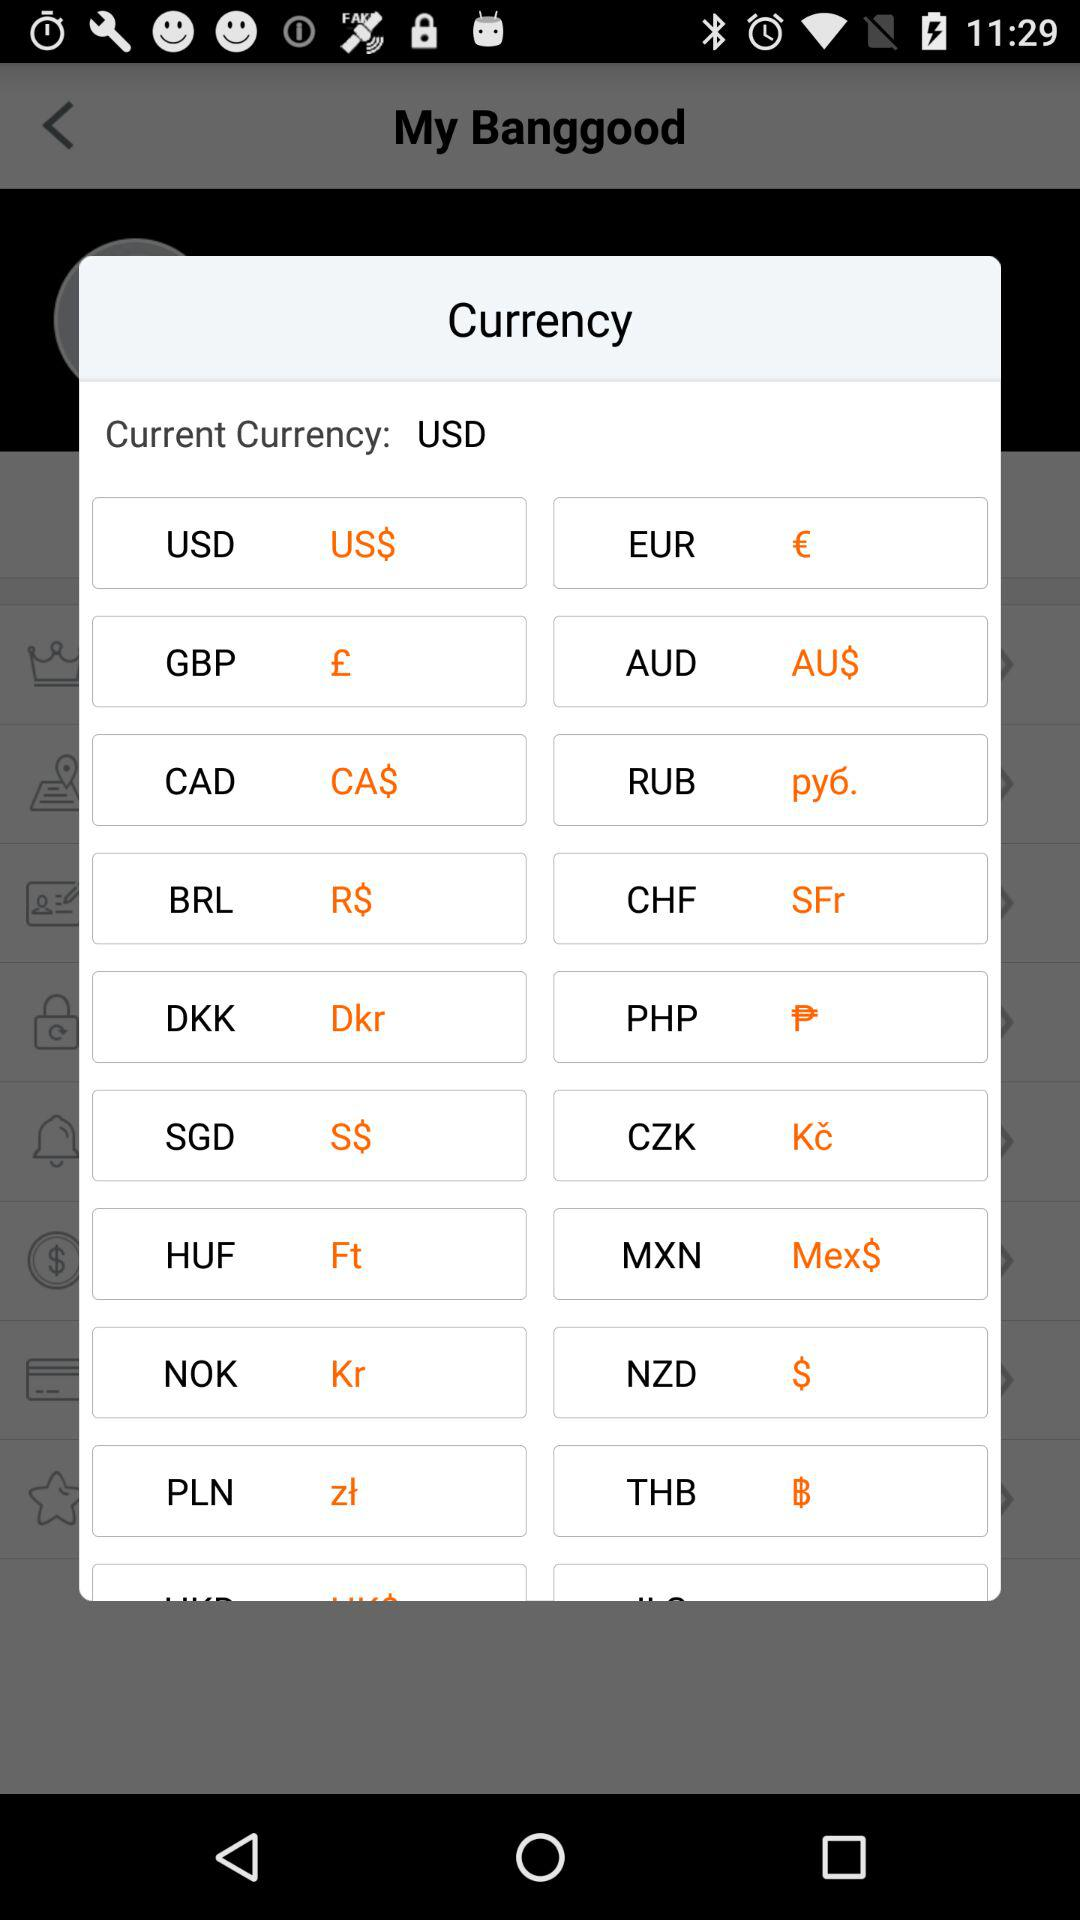What is the currency symbol for USD? The currency symbol for USD is US$. 